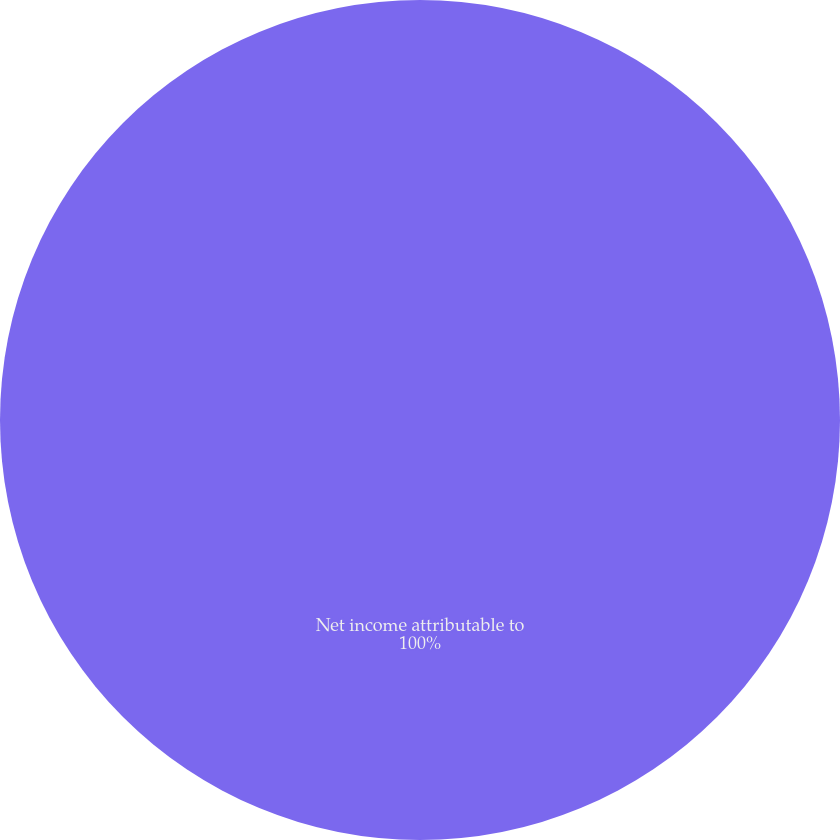<chart> <loc_0><loc_0><loc_500><loc_500><pie_chart><fcel>Net income attributable to<nl><fcel>100.0%<nl></chart> 